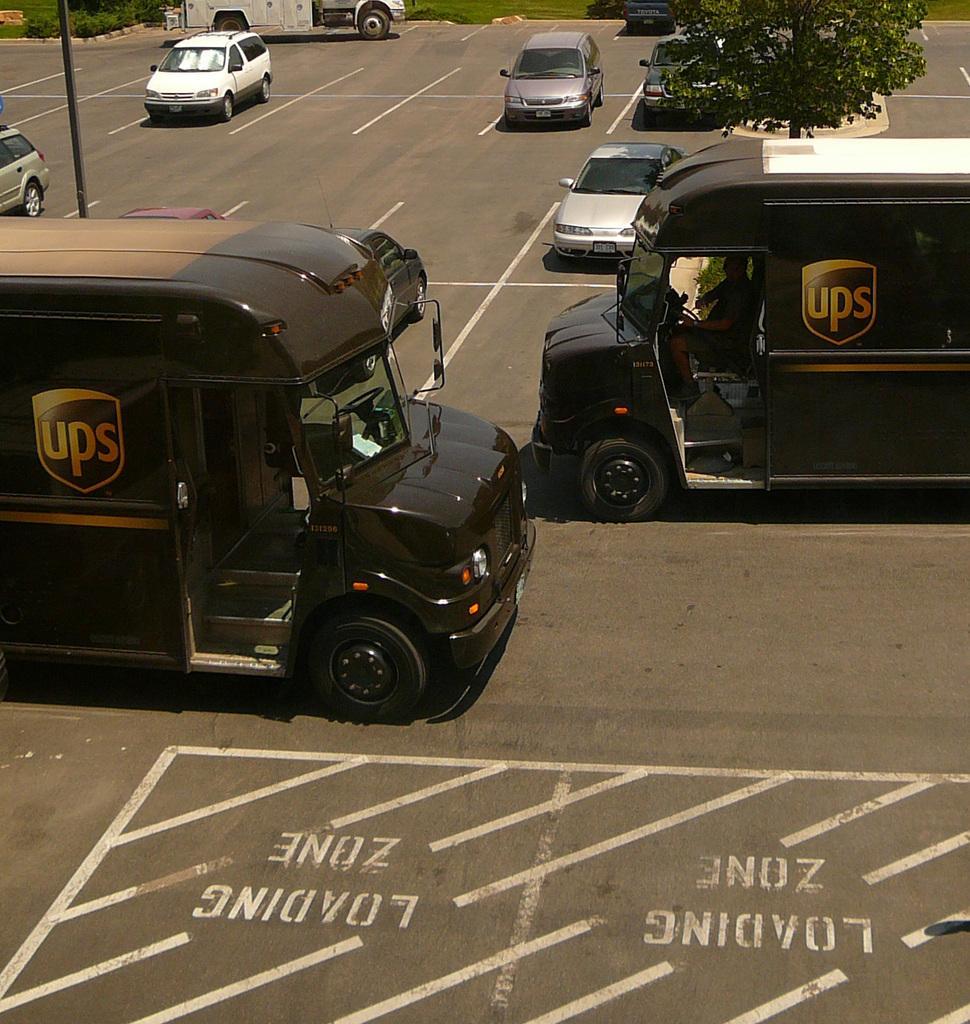Could you give a brief overview of what you see in this image? 2 Black color vehicles are moving on the road, on the right side there is a tree. On the left side few cars are moving on the road. 